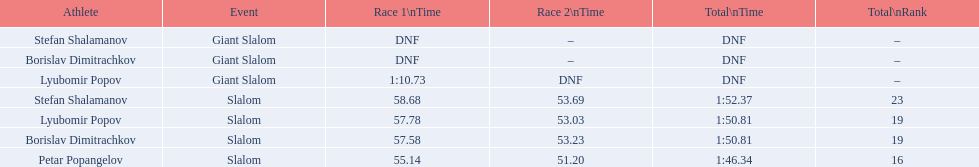What were the event names during bulgaria at the 1988 winter olympics? Stefan Shalamanov, Borislav Dimitrachkov, Lyubomir Popov. And which players participated at giant slalom? Giant Slalom, Giant Slalom, Giant Slalom, Slalom, Slalom, Slalom, Slalom. What were their race 1 times? DNF, DNF, 1:10.73. What was lyubomir popov's personal time? 1:10.73. 